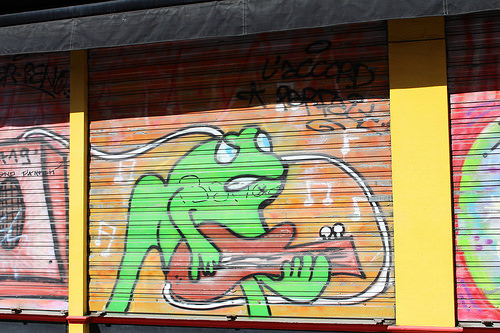<image>
Is there a frog behind the guitar? Yes. From this viewpoint, the frog is positioned behind the guitar, with the guitar partially or fully occluding the frog. 